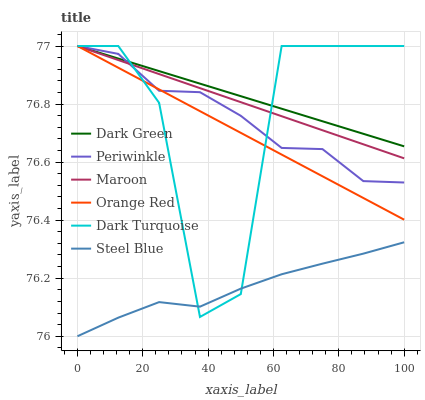Does Steel Blue have the minimum area under the curve?
Answer yes or no. Yes. Does Dark Green have the maximum area under the curve?
Answer yes or no. Yes. Does Maroon have the minimum area under the curve?
Answer yes or no. No. Does Maroon have the maximum area under the curve?
Answer yes or no. No. Is Dark Green the smoothest?
Answer yes or no. Yes. Is Dark Turquoise the roughest?
Answer yes or no. Yes. Is Steel Blue the smoothest?
Answer yes or no. No. Is Steel Blue the roughest?
Answer yes or no. No. Does Steel Blue have the lowest value?
Answer yes or no. Yes. Does Maroon have the lowest value?
Answer yes or no. No. Does Dark Green have the highest value?
Answer yes or no. Yes. Does Steel Blue have the highest value?
Answer yes or no. No. Is Steel Blue less than Periwinkle?
Answer yes or no. Yes. Is Maroon greater than Steel Blue?
Answer yes or no. Yes. Does Dark Turquoise intersect Periwinkle?
Answer yes or no. Yes. Is Dark Turquoise less than Periwinkle?
Answer yes or no. No. Is Dark Turquoise greater than Periwinkle?
Answer yes or no. No. Does Steel Blue intersect Periwinkle?
Answer yes or no. No. 